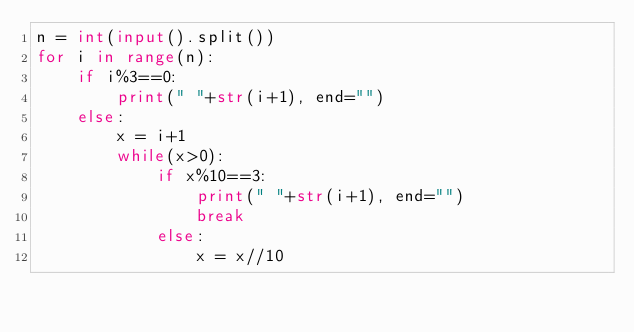Convert code to text. <code><loc_0><loc_0><loc_500><loc_500><_Python_>n = int(input().split())
for i in range(n):
    if i%3==0:
        print(" "+str(i+1), end="")
    else:
        x = i+1
        while(x>0):
            if x%10==3:
                print(" "+str(i+1), end="")
                break
            else:
                x = x//10</code> 